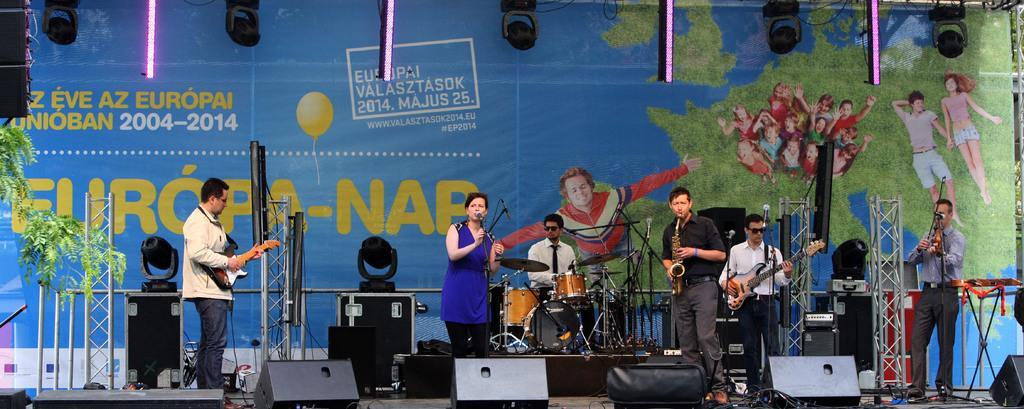Could you give a brief overview of what you see in this image? As we can see in the image, there are a group of people standing on stage and playing different types of musical instruments. The women who is standing in the middle is singing a song and in the background there is a blue color background. 